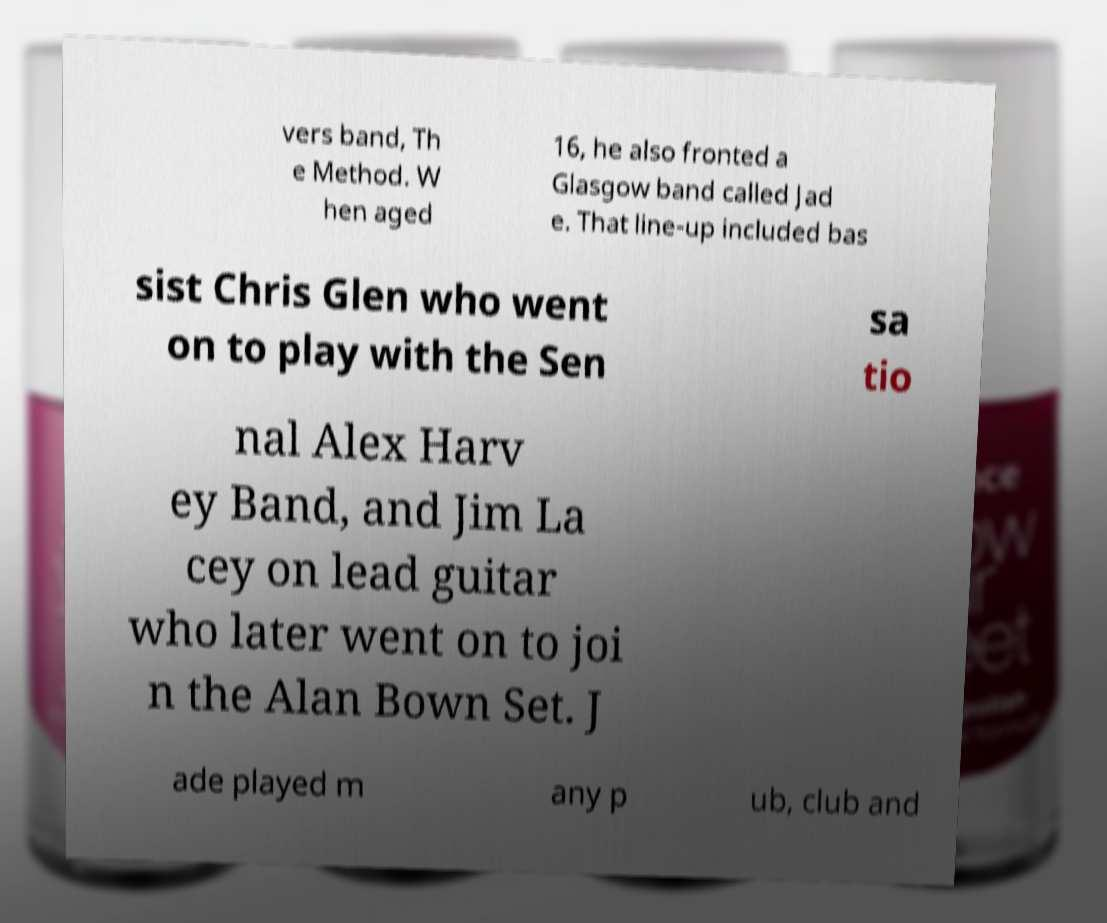Can you accurately transcribe the text from the provided image for me? vers band, Th e Method. W hen aged 16, he also fronted a Glasgow band called Jad e. That line-up included bas sist Chris Glen who went on to play with the Sen sa tio nal Alex Harv ey Band, and Jim La cey on lead guitar who later went on to joi n the Alan Bown Set. J ade played m any p ub, club and 